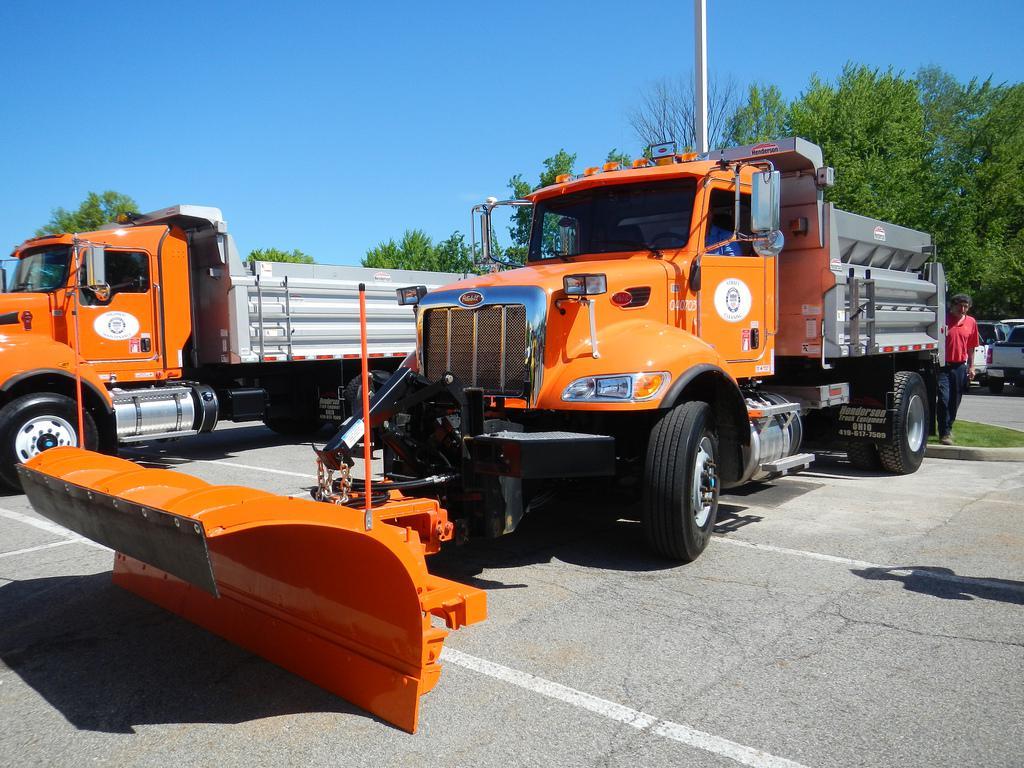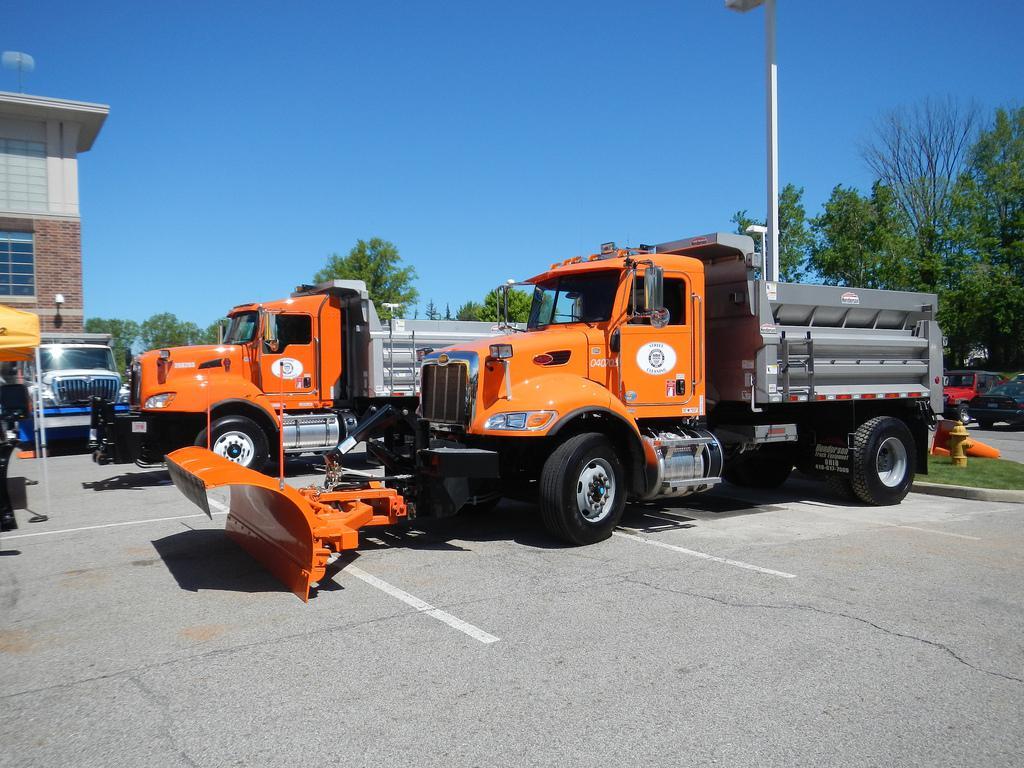The first image is the image on the left, the second image is the image on the right. For the images displayed, is the sentence "There is a snowplow plowing snow." factually correct? Answer yes or no. No. 